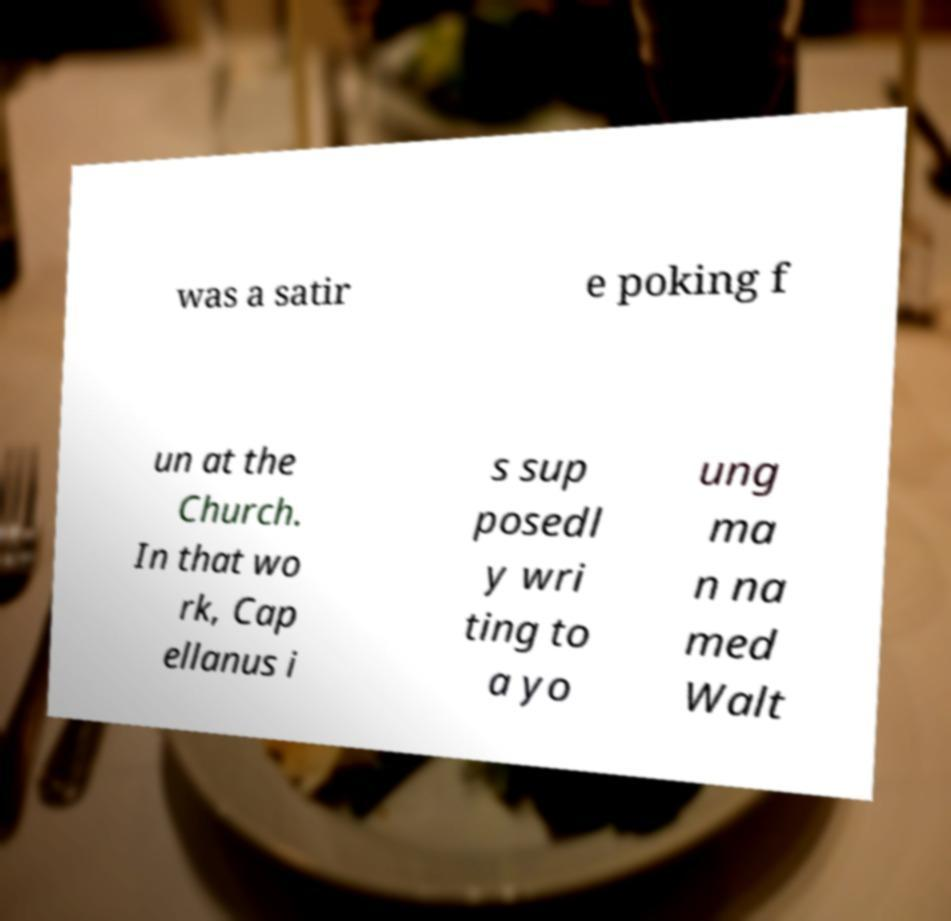For documentation purposes, I need the text within this image transcribed. Could you provide that? was a satir e poking f un at the Church. In that wo rk, Cap ellanus i s sup posedl y wri ting to a yo ung ma n na med Walt 